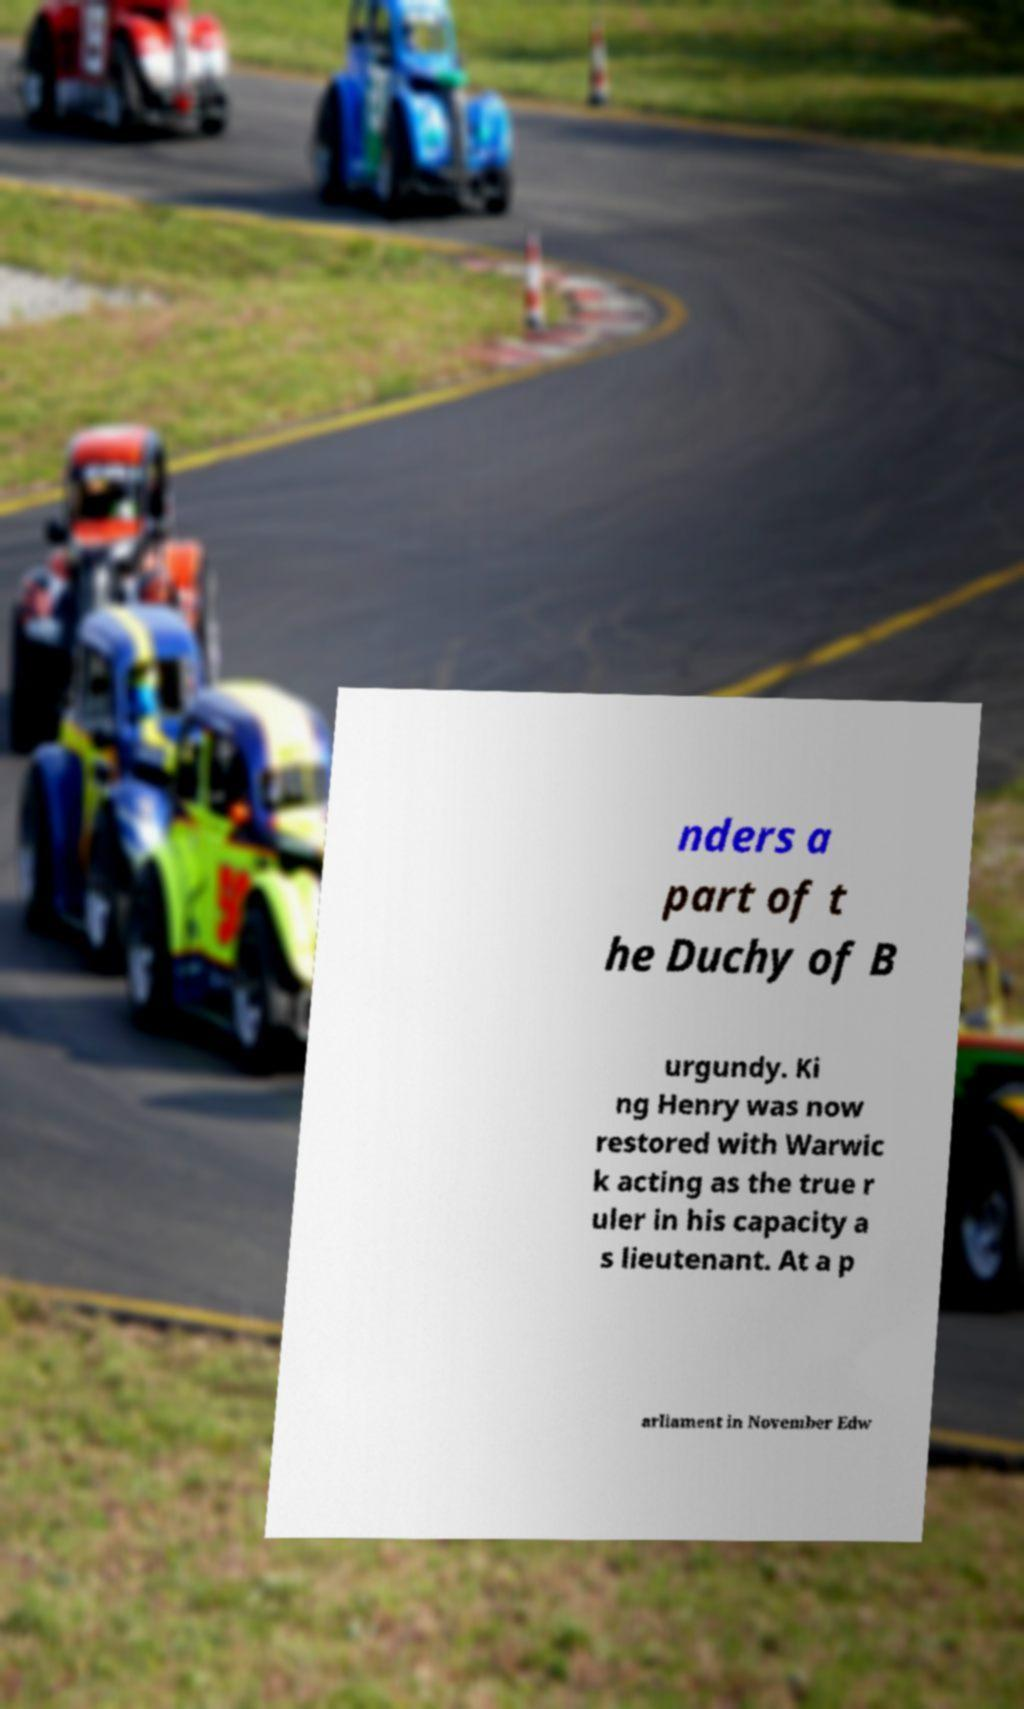Can you accurately transcribe the text from the provided image for me? nders a part of t he Duchy of B urgundy. Ki ng Henry was now restored with Warwic k acting as the true r uler in his capacity a s lieutenant. At a p arliament in November Edw 